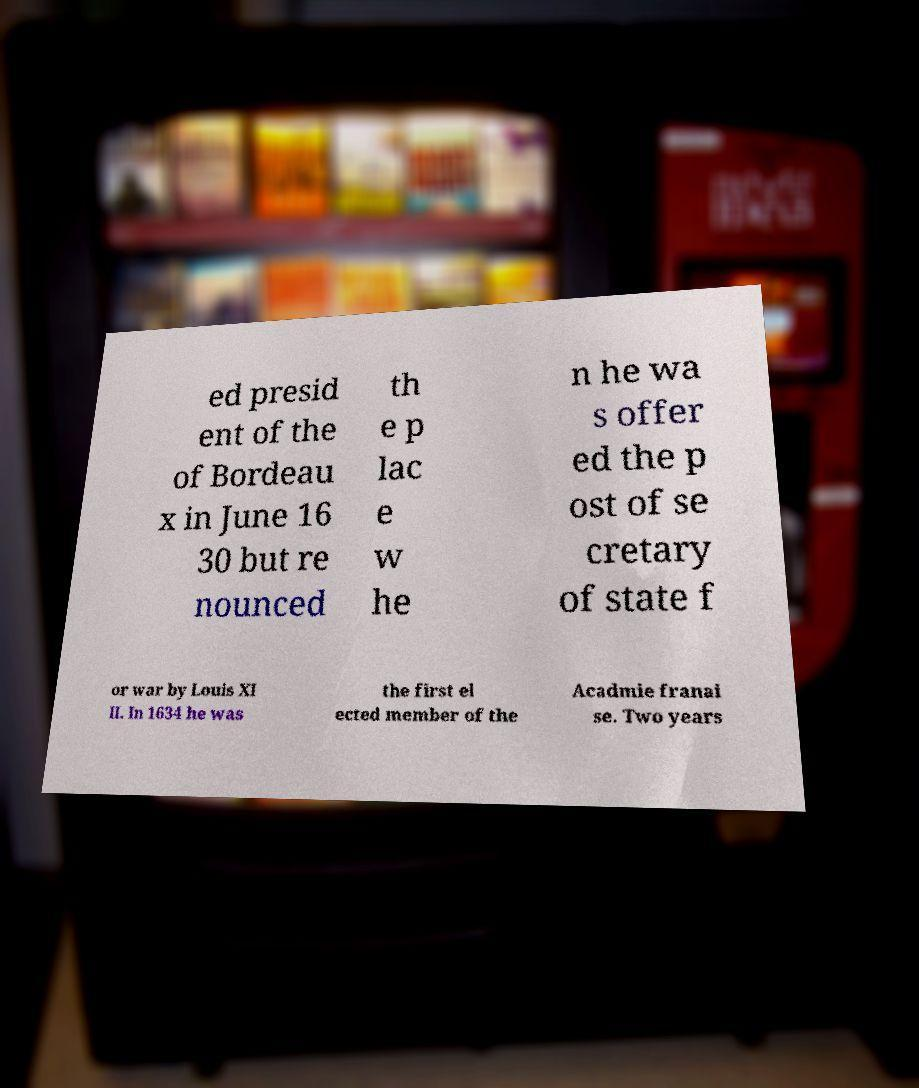Can you accurately transcribe the text from the provided image for me? ed presid ent of the of Bordeau x in June 16 30 but re nounced th e p lac e w he n he wa s offer ed the p ost of se cretary of state f or war by Louis XI II. In 1634 he was the first el ected member of the Acadmie franai se. Two years 